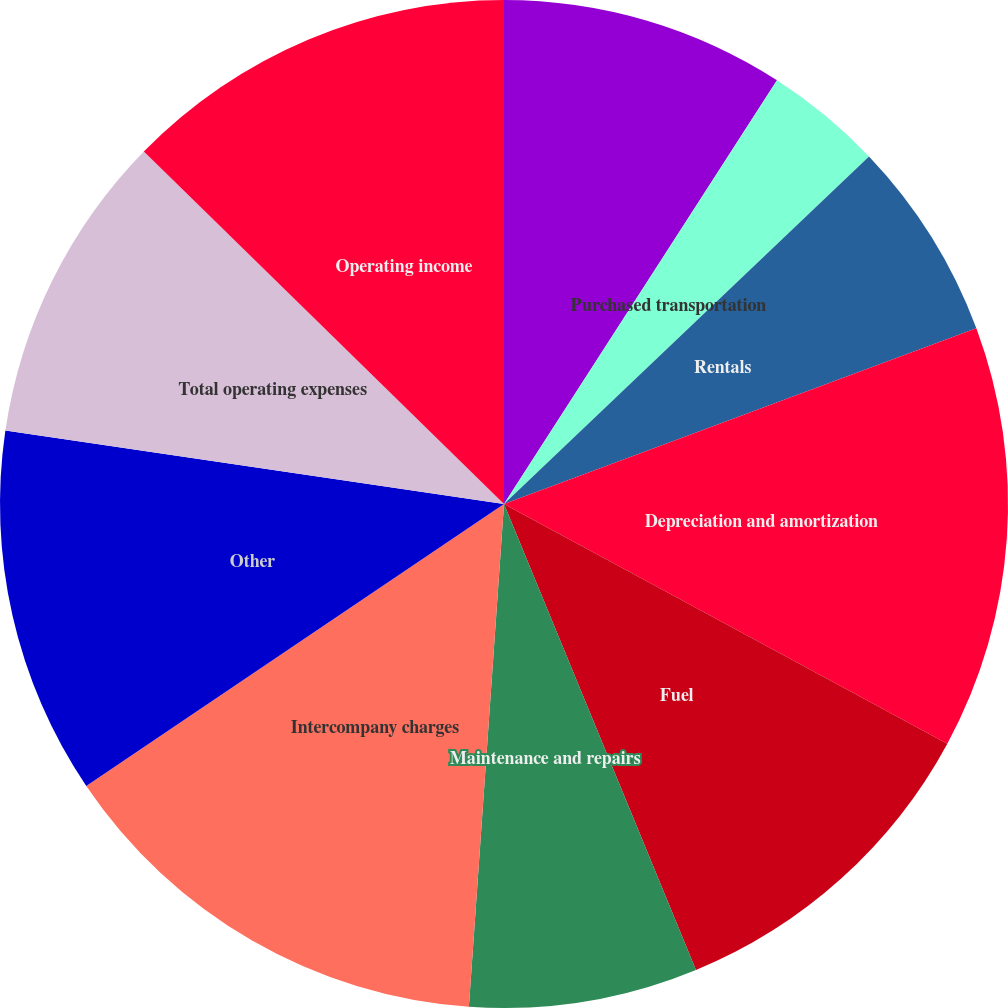<chart> <loc_0><loc_0><loc_500><loc_500><pie_chart><fcel>Salaries and employee benefits<fcel>Purchased transportation<fcel>Rentals<fcel>Depreciation and amortization<fcel>Fuel<fcel>Maintenance and repairs<fcel>Intercompany charges<fcel>Other<fcel>Total operating expenses<fcel>Operating income<nl><fcel>9.11%<fcel>3.78%<fcel>6.44%<fcel>13.56%<fcel>10.89%<fcel>7.33%<fcel>14.44%<fcel>11.78%<fcel>10.0%<fcel>12.67%<nl></chart> 